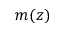Convert formula to latex. <formula><loc_0><loc_0><loc_500><loc_500>m ( z )</formula> 